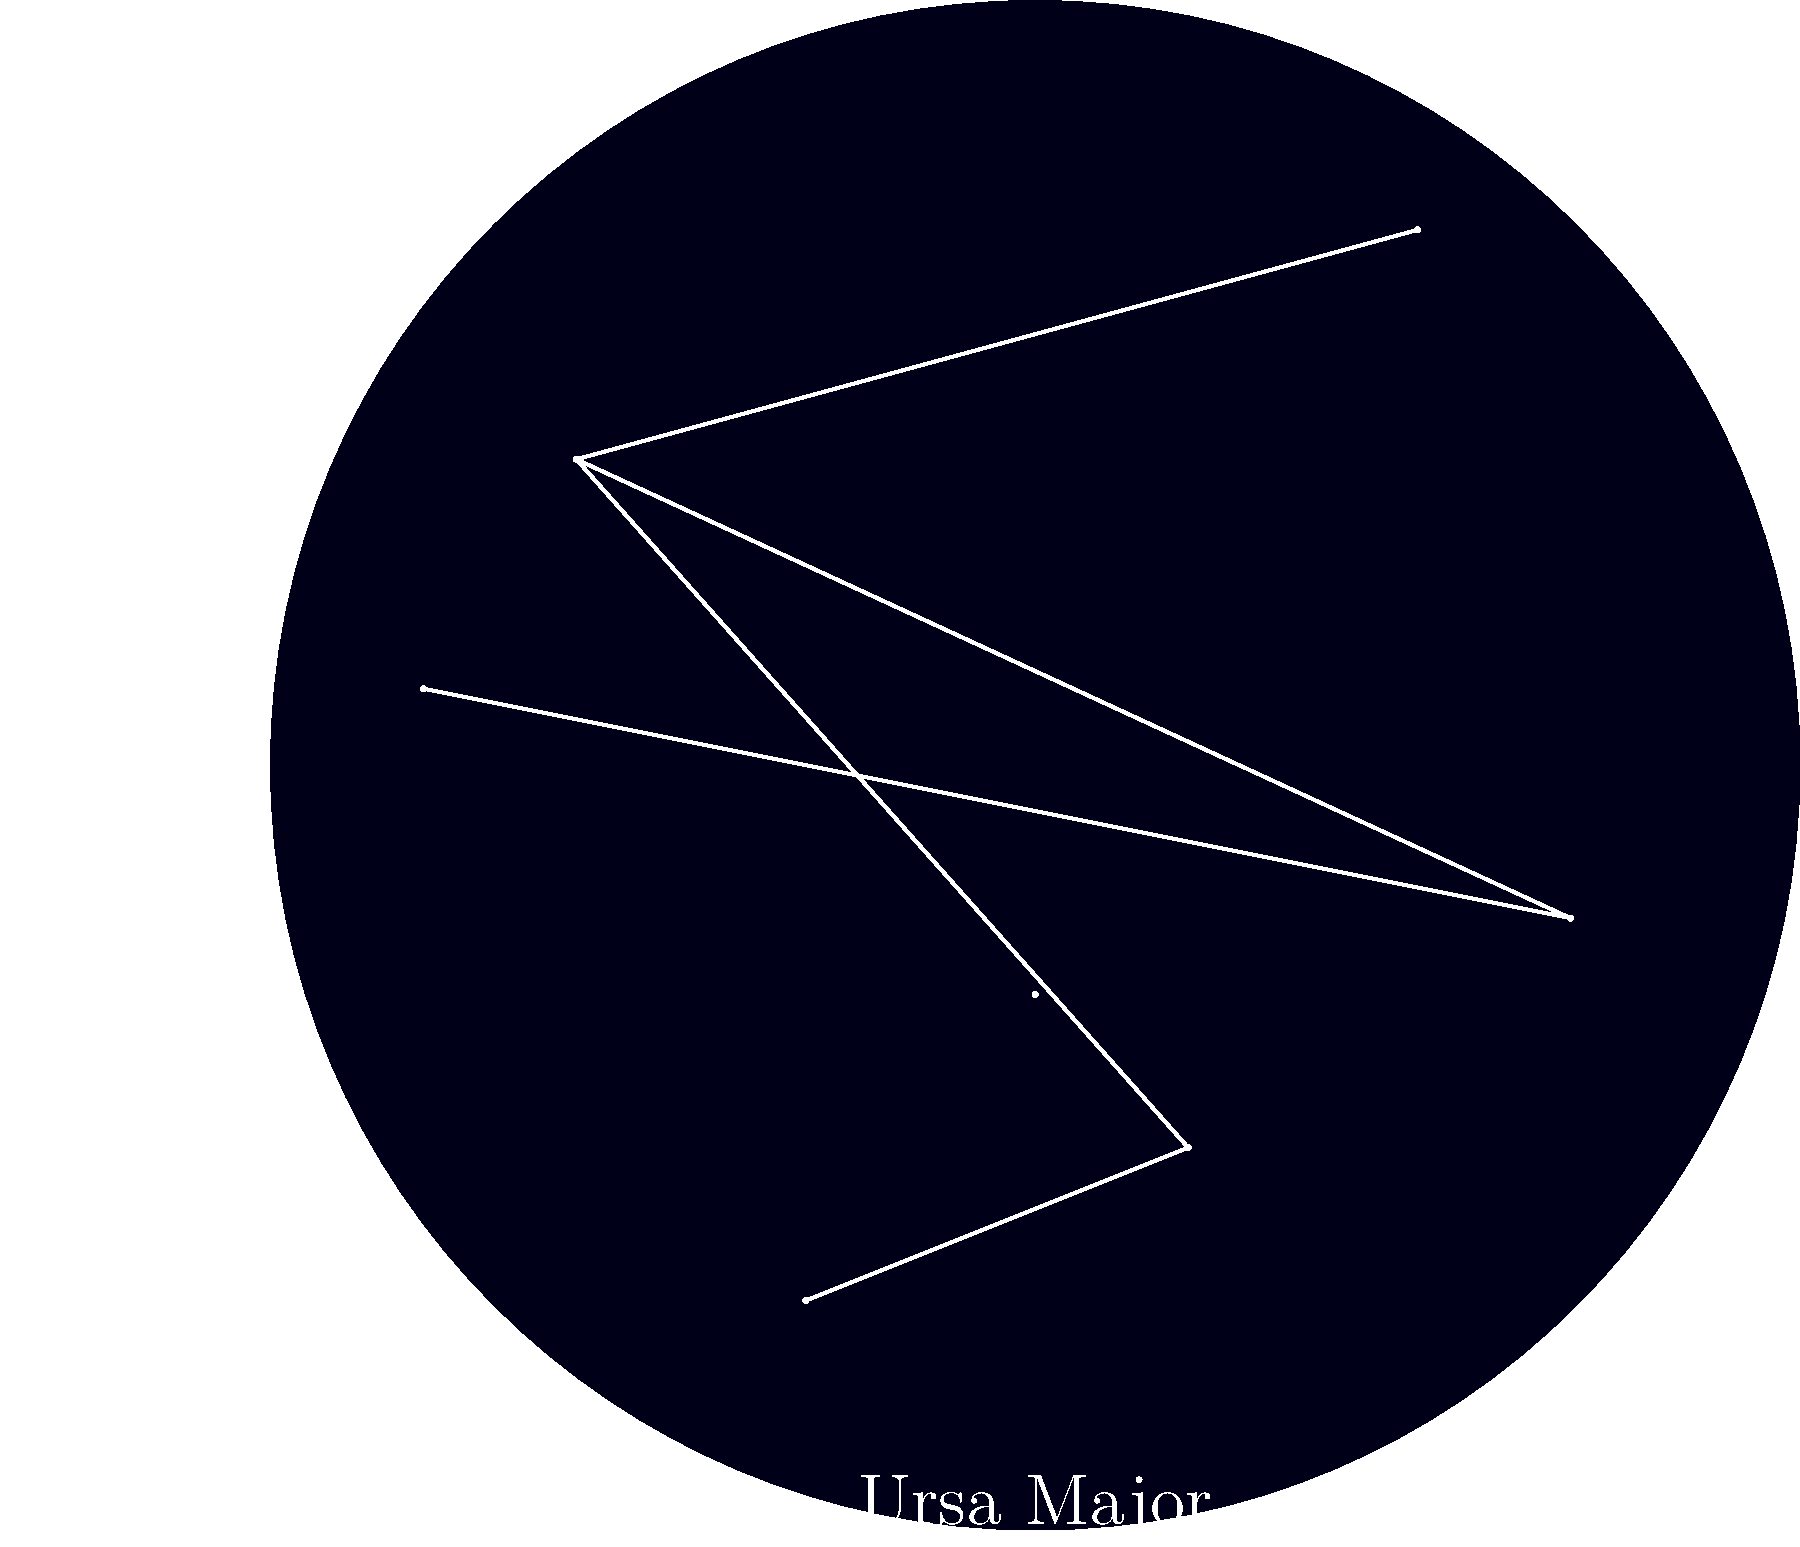As you gaze at the night sky from Bramall Lane, which constellation is represented by the W-shaped pattern of stars in the upper left of the star map? To answer this question, let's break it down step-by-step:

1. The star map shows a simplified view of the night sky as seen from Sheffield.

2. In the upper left corner of the map, we can see a distinct pattern of stars connected by lines.

3. This pattern forms a shape that resembles the letter "W" or a zigzag.

4. In astronomy, there's a well-known constellation that has this characteristic W shape.

5. This W-shaped constellation is Cassiopeia, named after the queen in Greek mythology.

6. Cassiopeia is one of the most easily recognizable constellations in the northern sky and is visible year-round from Sheffield due to its circumpolar nature.

7. The question specifically asks about a W-shaped pattern in the upper left of the star map, which matches the location and shape of Cassiopeia in our simplified star map.

Therefore, the constellation represented by the W-shaped pattern of stars in the upper left of the star map is Cassiopeia.
Answer: Cassiopeia 